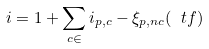Convert formula to latex. <formula><loc_0><loc_0><loc_500><loc_500>i = 1 + \sum _ { c \in \real } i _ { p , c } - \xi _ { p , n c } ( \ t f )</formula> 